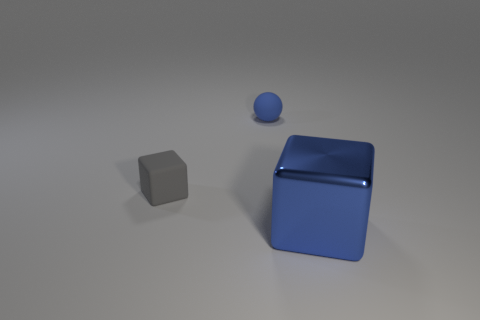Is there any indication of scale or size of these objects? Without additional context or points of reference in the image, such as familiar objects or measurements, it's challenging to accurately determine the scale or absolute size of the shapes. They could be miniature models or large structures. However, we can determine the relative sizes with respect to each other, where the blue cube is the largest, followed by the gray cube, and the blue sphere being the smallest object. 